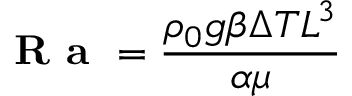Convert formula to latex. <formula><loc_0><loc_0><loc_500><loc_500>{ R a } = { \frac { \rho _ { 0 } g \beta \Delta T L ^ { 3 } } { \alpha \mu } }</formula> 